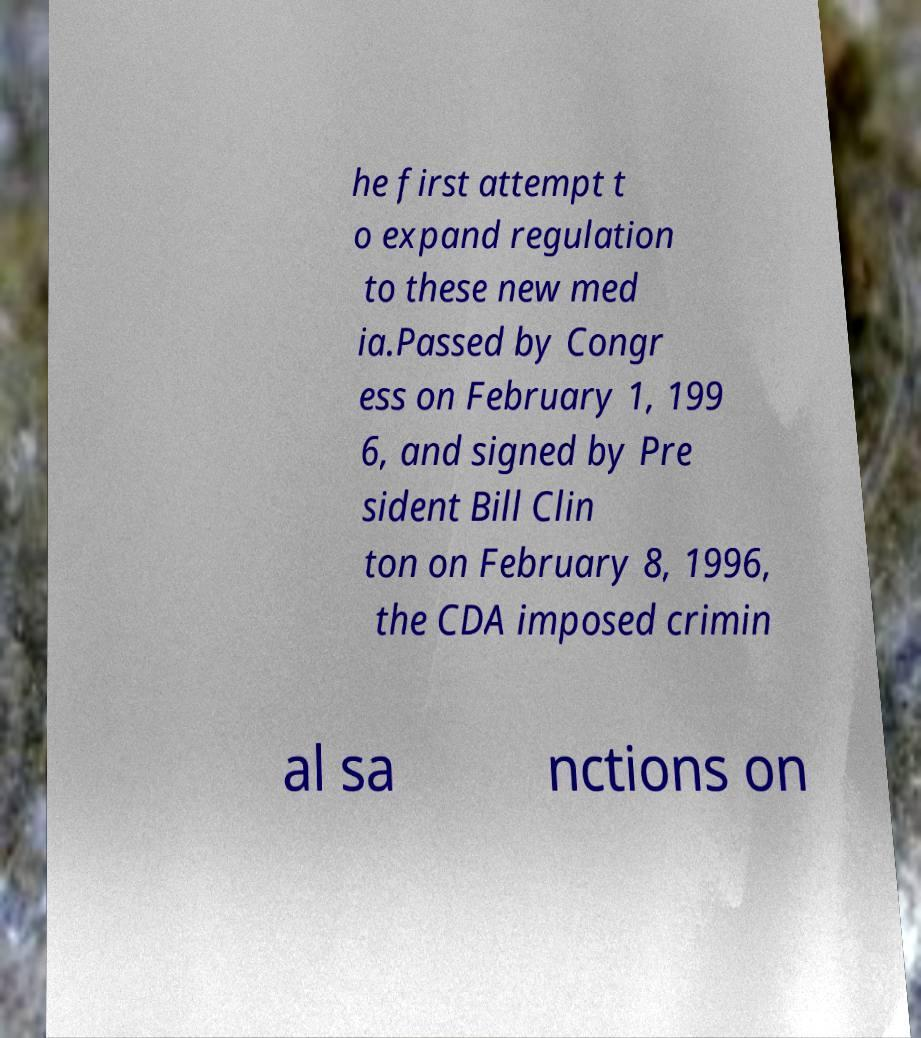Could you assist in decoding the text presented in this image and type it out clearly? he first attempt t o expand regulation to these new med ia.Passed by Congr ess on February 1, 199 6, and signed by Pre sident Bill Clin ton on February 8, 1996, the CDA imposed crimin al sa nctions on 